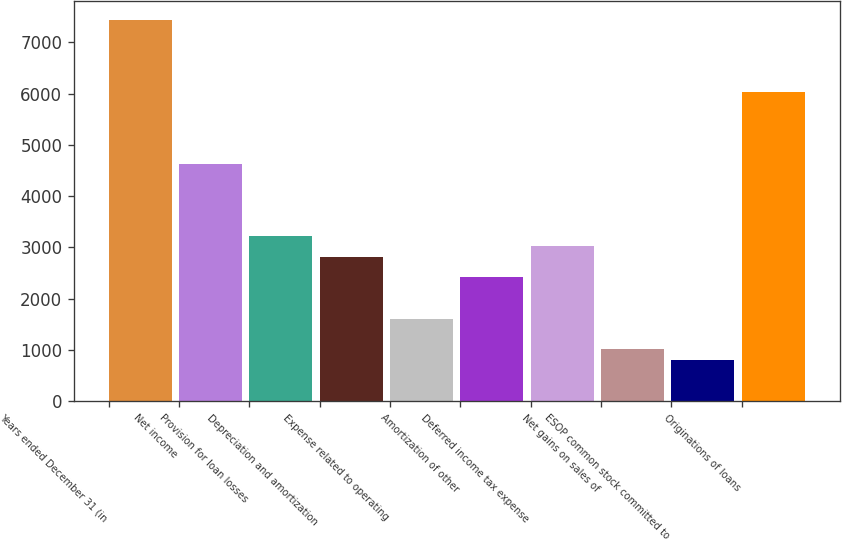Convert chart to OTSL. <chart><loc_0><loc_0><loc_500><loc_500><bar_chart><fcel>Years ended December 31 (in<fcel>Net income<fcel>Provision for loan losses<fcel>Depreciation and amortization<fcel>Expense related to operating<fcel>Amortization of other<fcel>Deferred income tax expense<fcel>Net gains on sales of<fcel>ESOP common stock committed to<fcel>Originations of loans<nl><fcel>7440.43<fcel>4625.17<fcel>3217.54<fcel>2815.36<fcel>1608.82<fcel>2413.18<fcel>3016.45<fcel>1005.55<fcel>804.46<fcel>6032.8<nl></chart> 